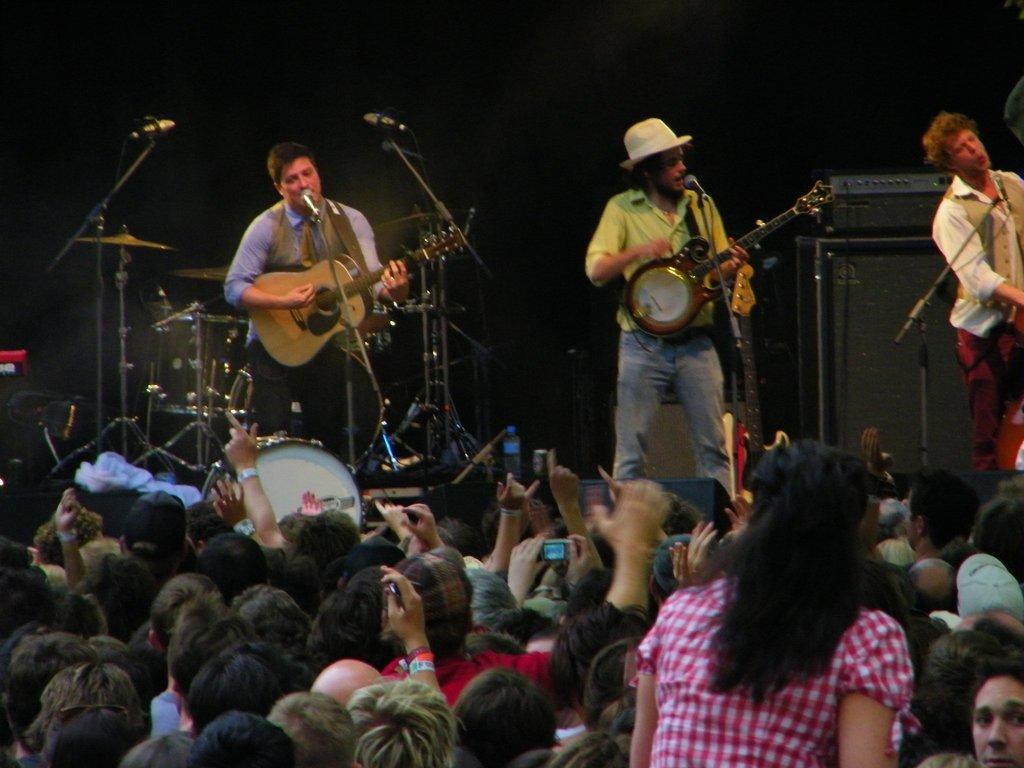In one or two sentences, can you explain what this image depicts? In this picture there are three people they are singing on the stage, there are two people they are holding the guitar on the stage and the one is singing in the mic, there are audience in front of them and there is a drum set, there is a speaker at the right side of the image. 